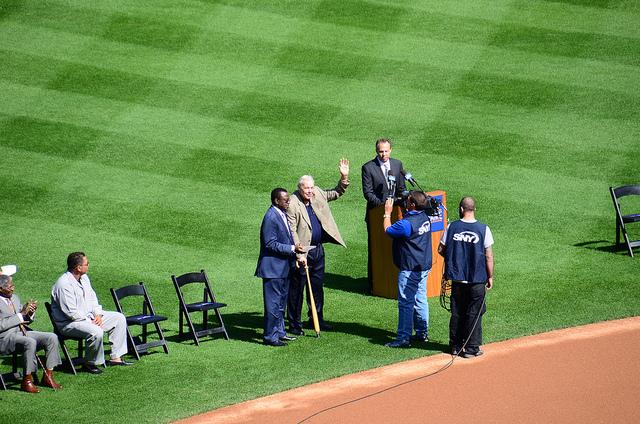How many empty chairs are there?
Give a very brief answer. 3. Why is the white man raising his hand?
Give a very brief answer. Waving. Are any of the men wearing hats?
Give a very brief answer. No. 